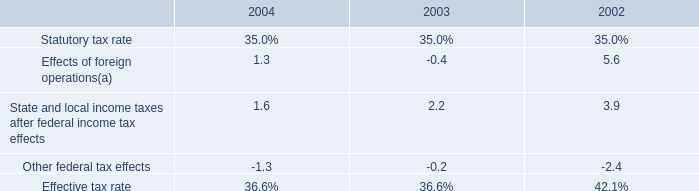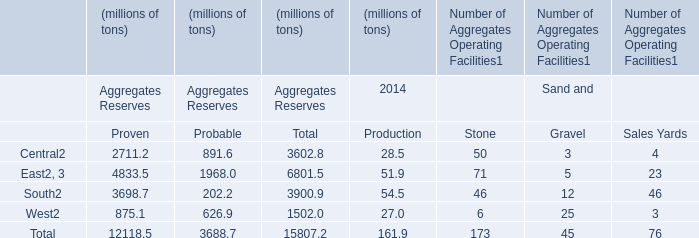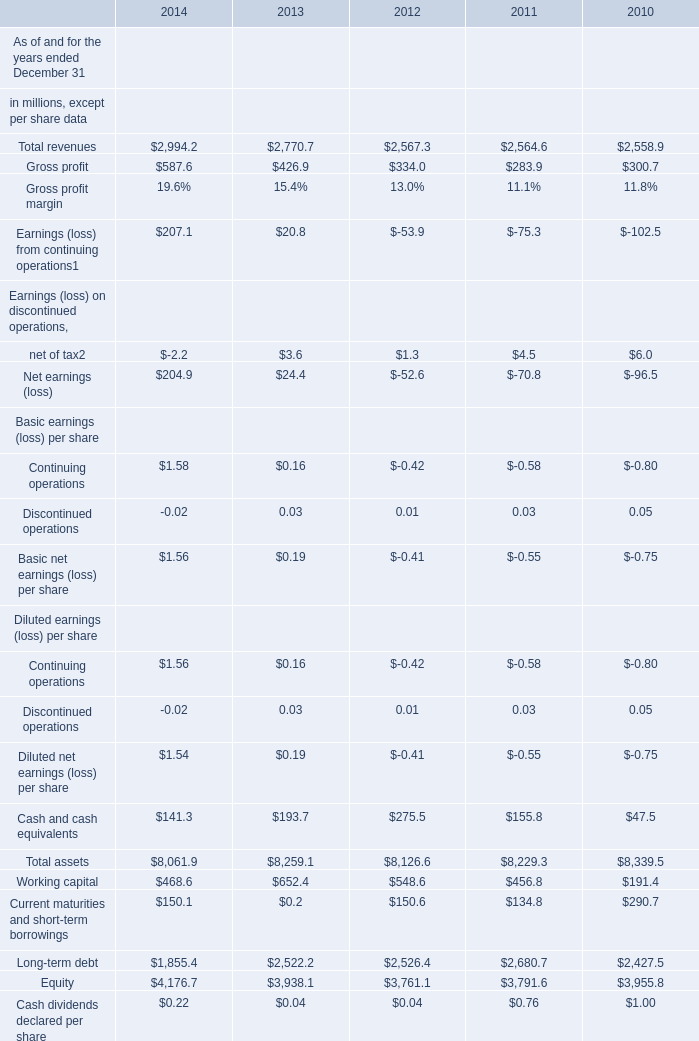What's the growth rate of the value of Total assets in 2012 ended December 31? 
Computations: ((8126.6 - 8229.3) / 8229.3)
Answer: -0.01248. 